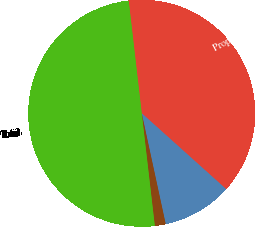Convert chart. <chart><loc_0><loc_0><loc_500><loc_500><pie_chart><fcel>Property acquisition costs<fcel>Exploration and development<fcel>Capitalized interest<fcel>Total<nl><fcel>38.48%<fcel>9.96%<fcel>1.55%<fcel>50.0%<nl></chart> 